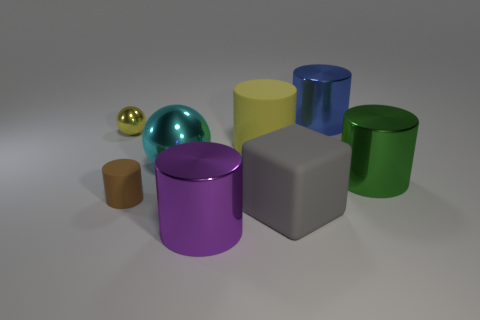Subtract all small rubber cylinders. How many cylinders are left? 4 Subtract all yellow balls. How many balls are left? 1 Subtract all cylinders. How many objects are left? 3 Add 1 cyan balls. How many objects exist? 9 Subtract 1 cylinders. How many cylinders are left? 4 Subtract all large red things. Subtract all big metallic things. How many objects are left? 4 Add 2 small matte cylinders. How many small matte cylinders are left? 3 Add 4 big gray matte spheres. How many big gray matte spheres exist? 4 Subtract 0 blue balls. How many objects are left? 8 Subtract all cyan cylinders. Subtract all blue balls. How many cylinders are left? 5 